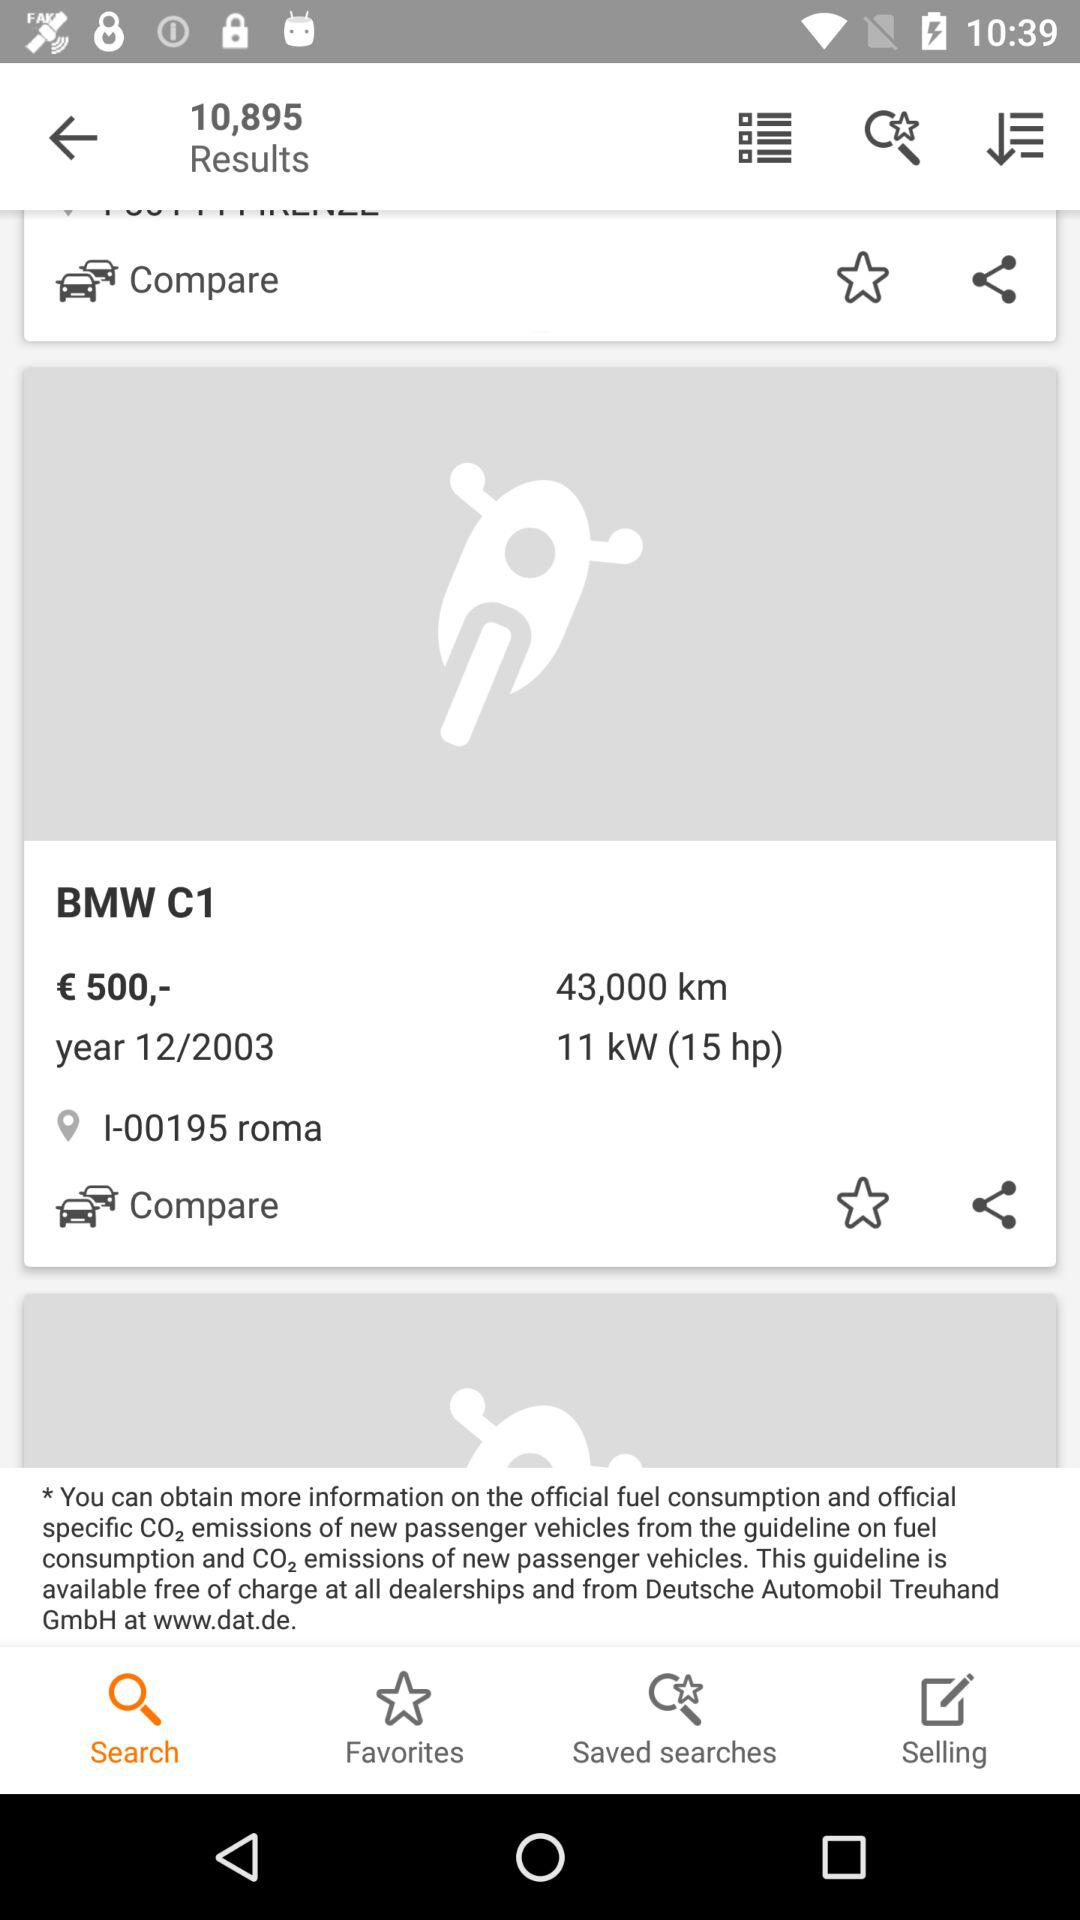What is the cost of the BMW C1? The cost is €500. 